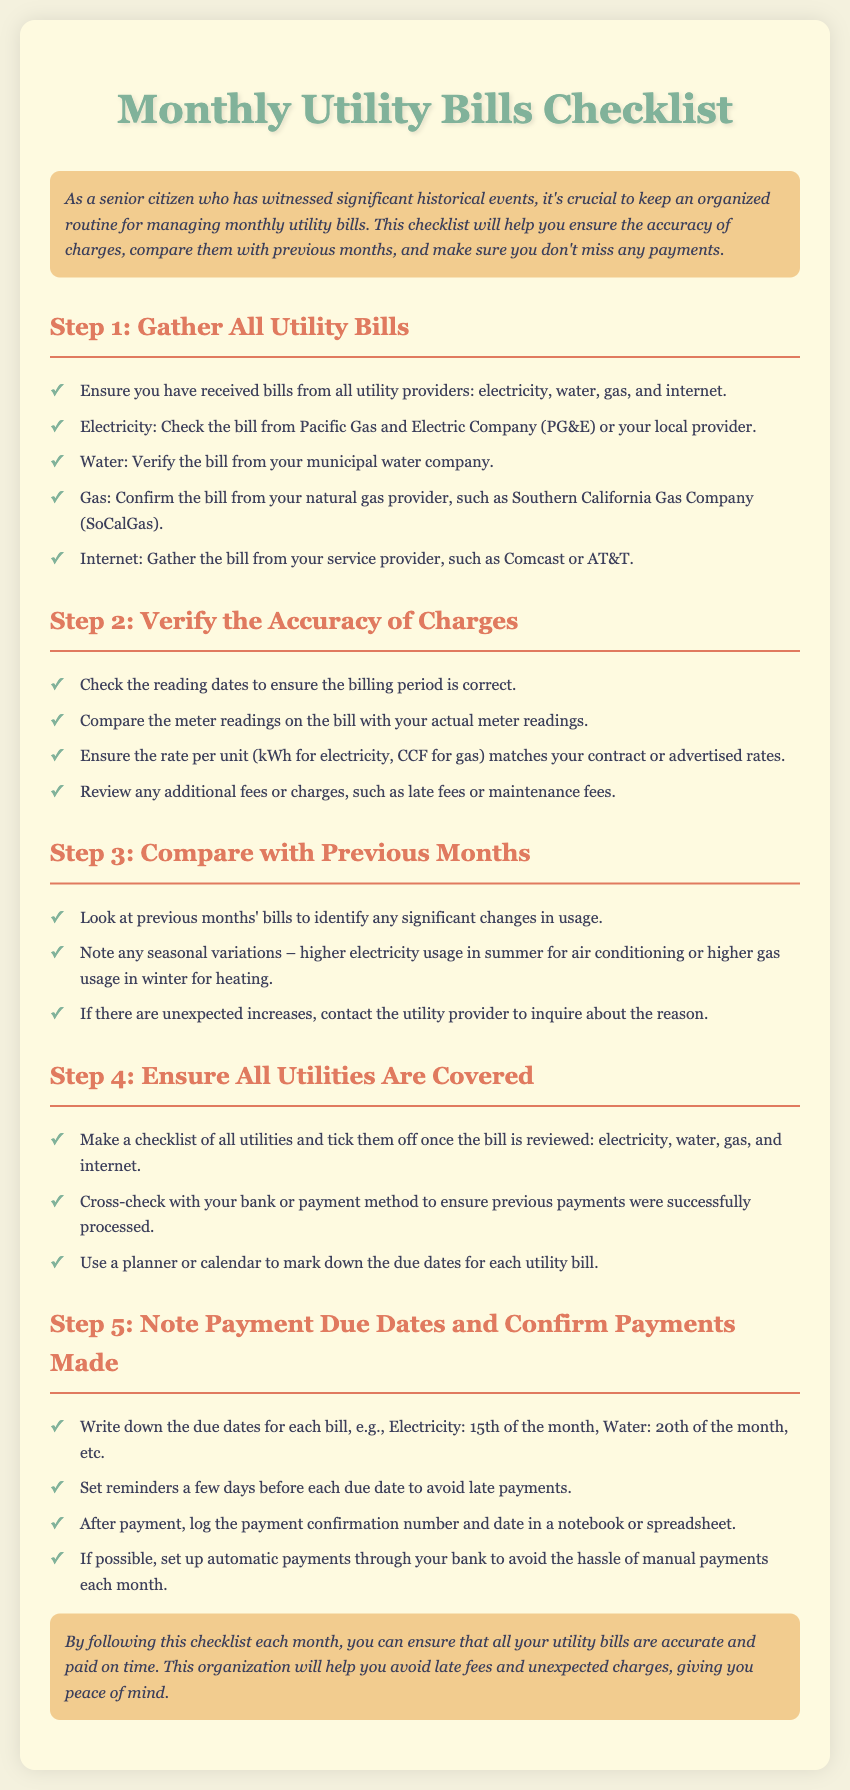What is the title of the checklist? The title of the checklist is prominently displayed at the top of the document.
Answer: Monthly Utility Bills Checklist What type of bills should be gathered? The checklist specifies the types of bills that need to be gathered in Step 1.
Answer: Electricity, water, gas, internet What is the payment due date for electricity? The checklist lists specific due dates for each utility bill in Step 5.
Answer: 15th of the month What should you verify in Step 2? Step 2 outlines the aspects of the bill that need verification for accuracy.
Answer: Accuracy of charges How can you avoid late payments? The checklist suggests actions in Step 5 to prevent late payments.
Answer: Set reminders Which company provides natural gas in Southern California? The document mentions a specific provider in Step 1 for gas bills.
Answer: Southern California Gas Company What should you cross-check with your bank? The checklist prompts you to ensure certain things while reviewing bills.
Answer: Previous payments What confirms that a payment was made? The checklist advises logging specific details after a payment is completed in Step 5.
Answer: Payment confirmation number and date 